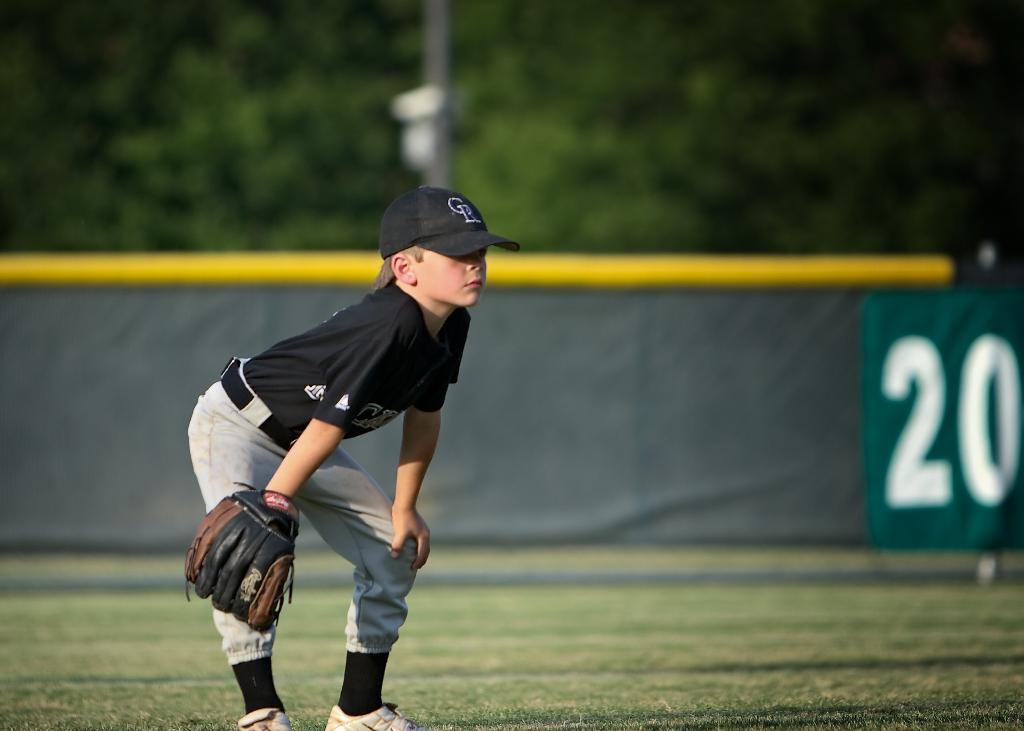Provide a one-sentence caption for the provided image. A young baseball player is watching for a catch near a sign that says 20. 